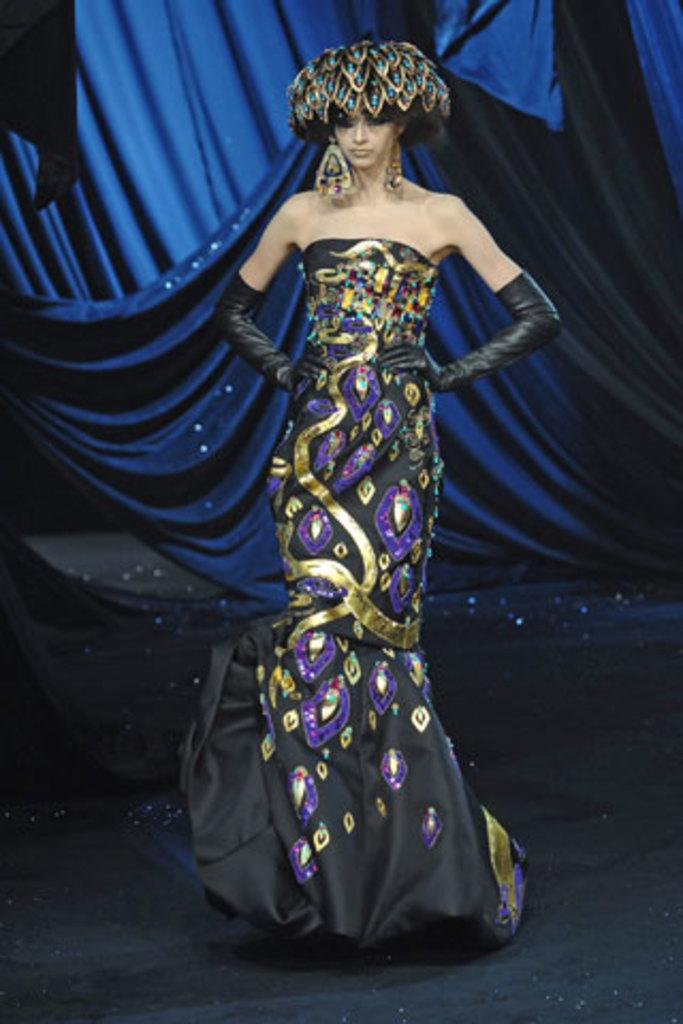What is the main subject of the image? There is a woman standing in the image. Can you describe the background of the image? There is a blue color cloth visible in the background of the image. What is the writer doing at the birthday party in the image? There is no writer or birthday party present in the image; it only features a woman standing in front of a blue color cloth. 